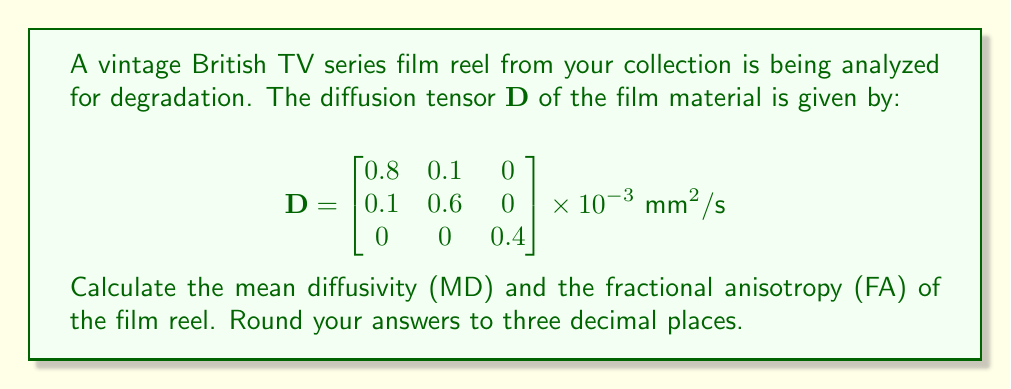Show me your answer to this math problem. To solve this problem, we need to follow these steps:

1) Calculate the mean diffusivity (MD):
   MD is the average of the eigenvalues of the diffusion tensor.
   
   $$\text{MD} = \frac{\text{Trace}(\mathbf{D})}{3} = \frac{D_{xx} + D_{yy} + D_{zz}}{3}$$
   
   $$\text{MD} = \frac{0.8 + 0.6 + 0.4}{3} \times 10^{-3} = 0.6 \times 10^{-3} \text{ mm}^2/\text{s}$$

2) Calculate the fractional anisotropy (FA):
   FA is a measure of the anisotropy of diffusion, ranging from 0 (isotropic) to 1 (anisotropic).
   
   The formula for FA is:
   
   $$\text{FA} = \sqrt{\frac{3}{2}} \sqrt{\frac{(\lambda_1 - \bar{\lambda})^2 + (\lambda_2 - \bar{\lambda})^2 + (\lambda_3 - \bar{\lambda})^2}{\lambda_1^2 + \lambda_2^2 + \lambda_3^2}}$$
   
   where $\lambda_1$, $\lambda_2$, and $\lambda_3$ are the eigenvalues of $\mathbf{D}$, and $\bar{\lambda}$ is their mean.

3) Find the eigenvalues:
   For a symmetric 3x3 matrix, the eigenvalues are the roots of the characteristic equation:
   
   $$\det(\mathbf{D} - \lambda \mathbf{I}) = 0$$
   
   Solving this equation (which is complex and typically done numerically), we get:
   
   $\lambda_1 \approx 0.825 \times 10^{-3}$, $\lambda_2 \approx 0.575 \times 10^{-3}$, $\lambda_3 = 0.4 \times 10^{-3}$

4) Calculate FA:
   
   $$\bar{\lambda} = \frac{0.825 + 0.575 + 0.4}{3} \times 10^{-3} = 0.6 \times 10^{-3}$$
   
   $$\text{FA} = \sqrt{\frac{3}{2}} \sqrt{\frac{(0.825 - 0.6)^2 + (0.575 - 0.6)^2 + (0.4 - 0.6)^2}{0.825^2 + 0.575^2 + 0.4^2}} \times 10^{-3}$$
   
   $$\text{FA} \approx 0.283$$

5) Round both results to three decimal places.
Answer: MD = 0.600 × 10^-3 mm^2/s, FA = 0.283 